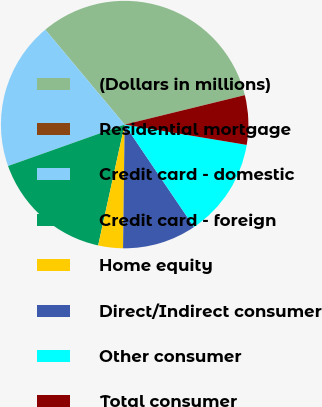Convert chart. <chart><loc_0><loc_0><loc_500><loc_500><pie_chart><fcel>(Dollars in millions)<fcel>Residential mortgage<fcel>Credit card - domestic<fcel>Credit card - foreign<fcel>Home equity<fcel>Direct/Indirect consumer<fcel>Other consumer<fcel>Total consumer<nl><fcel>32.26%<fcel>0.0%<fcel>19.35%<fcel>16.13%<fcel>3.23%<fcel>9.68%<fcel>12.9%<fcel>6.45%<nl></chart> 